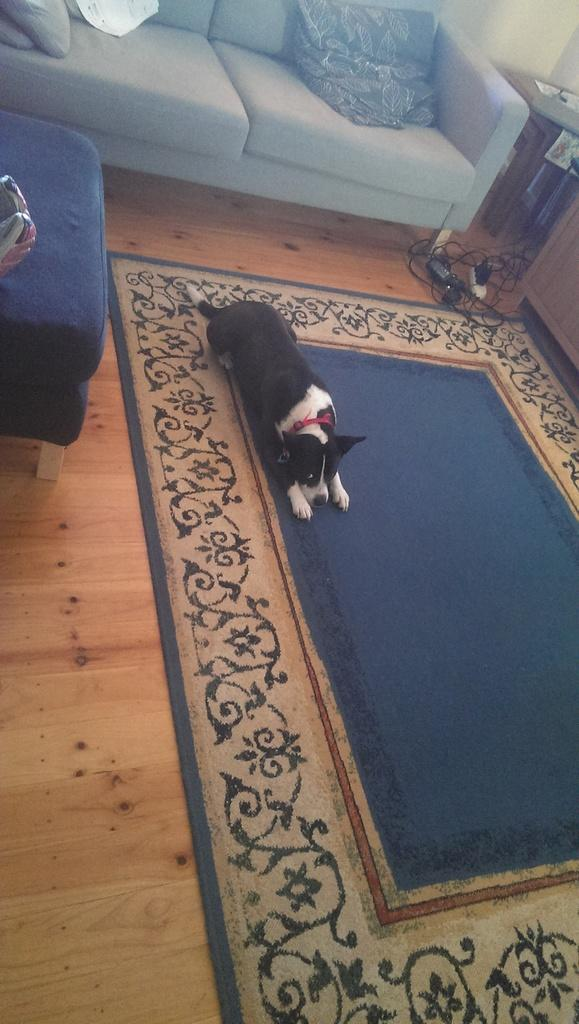What is on the carpet in the image? There is a dog on the carpet in the image. Where is the carpet located? The carpet is on the floor in the image. What can be seen in the background of the image? There are sofas, a wall, and a table in the background of the image. What is the price of the dog in the image? The price of the dog cannot be determined from the image, as it does not provide any information about the cost of the dog. 